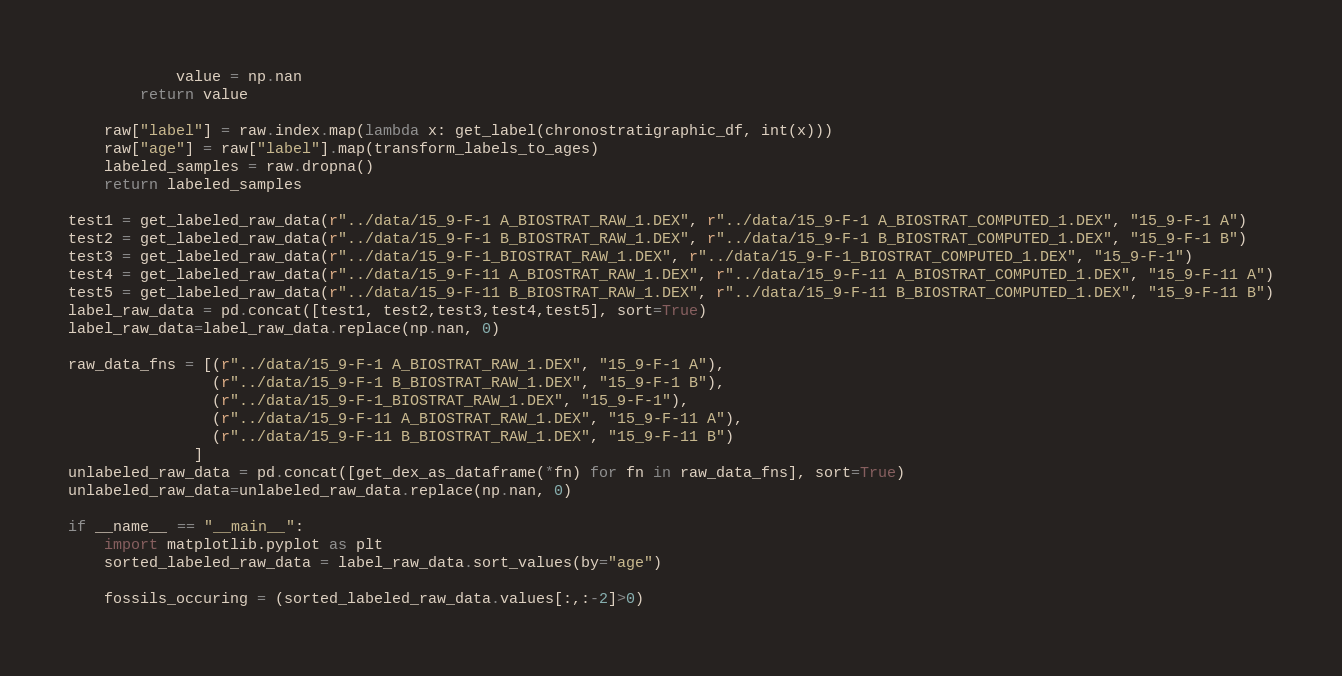<code> <loc_0><loc_0><loc_500><loc_500><_Python_>            value = np.nan
        return value
    
    raw["label"] = raw.index.map(lambda x: get_label(chronostratigraphic_df, int(x)))
    raw["age"] = raw["label"].map(transform_labels_to_ages)
    labeled_samples = raw.dropna()
    return labeled_samples

test1 = get_labeled_raw_data(r"../data/15_9-F-1 A_BIOSTRAT_RAW_1.DEX", r"../data/15_9-F-1 A_BIOSTRAT_COMPUTED_1.DEX", "15_9-F-1 A")
test2 = get_labeled_raw_data(r"../data/15_9-F-1 B_BIOSTRAT_RAW_1.DEX", r"../data/15_9-F-1 B_BIOSTRAT_COMPUTED_1.DEX", "15_9-F-1 B")
test3 = get_labeled_raw_data(r"../data/15_9-F-1_BIOSTRAT_RAW_1.DEX", r"../data/15_9-F-1_BIOSTRAT_COMPUTED_1.DEX", "15_9-F-1")
test4 = get_labeled_raw_data(r"../data/15_9-F-11 A_BIOSTRAT_RAW_1.DEX", r"../data/15_9-F-11 A_BIOSTRAT_COMPUTED_1.DEX", "15_9-F-11 A")
test5 = get_labeled_raw_data(r"../data/15_9-F-11 B_BIOSTRAT_RAW_1.DEX", r"../data/15_9-F-11 B_BIOSTRAT_COMPUTED_1.DEX", "15_9-F-11 B")
label_raw_data = pd.concat([test1, test2,test3,test4,test5], sort=True)
label_raw_data=label_raw_data.replace(np.nan, 0)

raw_data_fns = [(r"../data/15_9-F-1 A_BIOSTRAT_RAW_1.DEX", "15_9-F-1 A"), 
                (r"../data/15_9-F-1 B_BIOSTRAT_RAW_1.DEX", "15_9-F-1 B"),
                (r"../data/15_9-F-1_BIOSTRAT_RAW_1.DEX", "15_9-F-1"),
                (r"../data/15_9-F-11 A_BIOSTRAT_RAW_1.DEX", "15_9-F-11 A"),
                (r"../data/15_9-F-11 B_BIOSTRAT_RAW_1.DEX", "15_9-F-11 B")
              ]
unlabeled_raw_data = pd.concat([get_dex_as_dataframe(*fn) for fn in raw_data_fns], sort=True)
unlabeled_raw_data=unlabeled_raw_data.replace(np.nan, 0)

if __name__ == "__main__":
    import matplotlib.pyplot as plt
    sorted_labeled_raw_data = label_raw_data.sort_values(by="age")
    
    fossils_occuring = (sorted_labeled_raw_data.values[:,:-2]>0)</code> 